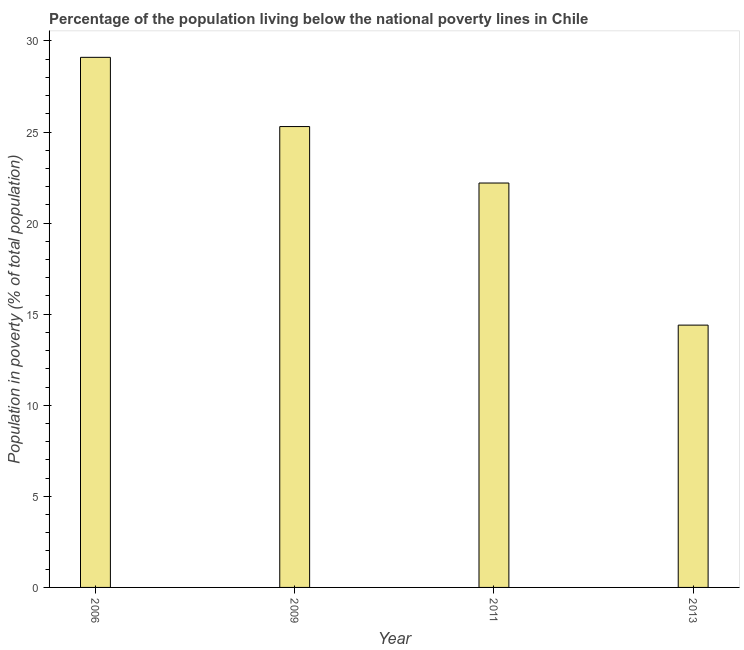What is the title of the graph?
Your response must be concise. Percentage of the population living below the national poverty lines in Chile. What is the label or title of the Y-axis?
Offer a terse response. Population in poverty (% of total population). Across all years, what is the maximum percentage of population living below poverty line?
Give a very brief answer. 29.1. In which year was the percentage of population living below poverty line maximum?
Provide a short and direct response. 2006. What is the sum of the percentage of population living below poverty line?
Your answer should be very brief. 91. What is the average percentage of population living below poverty line per year?
Ensure brevity in your answer.  22.75. What is the median percentage of population living below poverty line?
Keep it short and to the point. 23.75. In how many years, is the percentage of population living below poverty line greater than 15 %?
Your answer should be compact. 3. Do a majority of the years between 2009 and 2013 (inclusive) have percentage of population living below poverty line greater than 24 %?
Your answer should be compact. No. What is the ratio of the percentage of population living below poverty line in 2006 to that in 2009?
Provide a succinct answer. 1.15. Is the percentage of population living below poverty line in 2006 less than that in 2013?
Provide a succinct answer. No. What is the difference between the highest and the lowest percentage of population living below poverty line?
Give a very brief answer. 14.7. How many bars are there?
Your response must be concise. 4. How many years are there in the graph?
Offer a terse response. 4. What is the Population in poverty (% of total population) in 2006?
Offer a terse response. 29.1. What is the Population in poverty (% of total population) in 2009?
Your response must be concise. 25.3. What is the Population in poverty (% of total population) in 2011?
Offer a very short reply. 22.2. What is the Population in poverty (% of total population) of 2013?
Offer a terse response. 14.4. What is the difference between the Population in poverty (% of total population) in 2009 and 2011?
Keep it short and to the point. 3.1. What is the difference between the Population in poverty (% of total population) in 2009 and 2013?
Offer a very short reply. 10.9. What is the ratio of the Population in poverty (% of total population) in 2006 to that in 2009?
Make the answer very short. 1.15. What is the ratio of the Population in poverty (% of total population) in 2006 to that in 2011?
Make the answer very short. 1.31. What is the ratio of the Population in poverty (% of total population) in 2006 to that in 2013?
Keep it short and to the point. 2.02. What is the ratio of the Population in poverty (% of total population) in 2009 to that in 2011?
Ensure brevity in your answer.  1.14. What is the ratio of the Population in poverty (% of total population) in 2009 to that in 2013?
Your response must be concise. 1.76. What is the ratio of the Population in poverty (% of total population) in 2011 to that in 2013?
Ensure brevity in your answer.  1.54. 